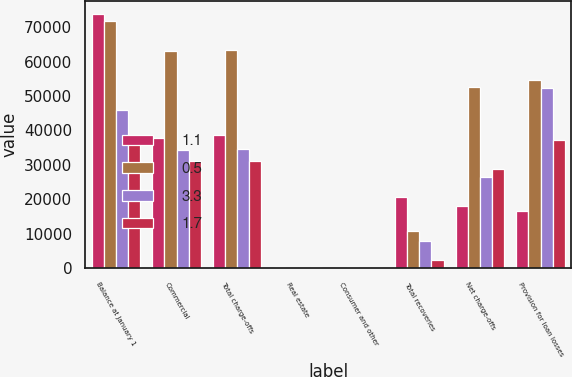<chart> <loc_0><loc_0><loc_500><loc_500><stacked_bar_chart><ecel><fcel>Balance at January 1<fcel>Commercial<fcel>Total charge-offs<fcel>Real estate<fcel>Consumer and other<fcel>Total recoveries<fcel>Net charge-offs<fcel>Provision for loan losses<nl><fcel>1.1<fcel>73800<fcel>37671<fcel>38785<fcel>209<fcel>19<fcel>20636<fcel>18149<fcel>16724<nl><fcel>0.5<fcel>71800<fcel>63177<fcel>63380<fcel>47<fcel>224<fcel>10778<fcel>52602<fcel>54602<nl><fcel>3.3<fcel>46000<fcel>34312<fcel>34508<fcel>34<fcel>18<fcel>7901<fcel>26607<fcel>52407<nl><fcel>1.7<fcel>37700<fcel>31123<fcel>31123<fcel>366<fcel>1<fcel>2264<fcel>28859<fcel>37159<nl></chart> 